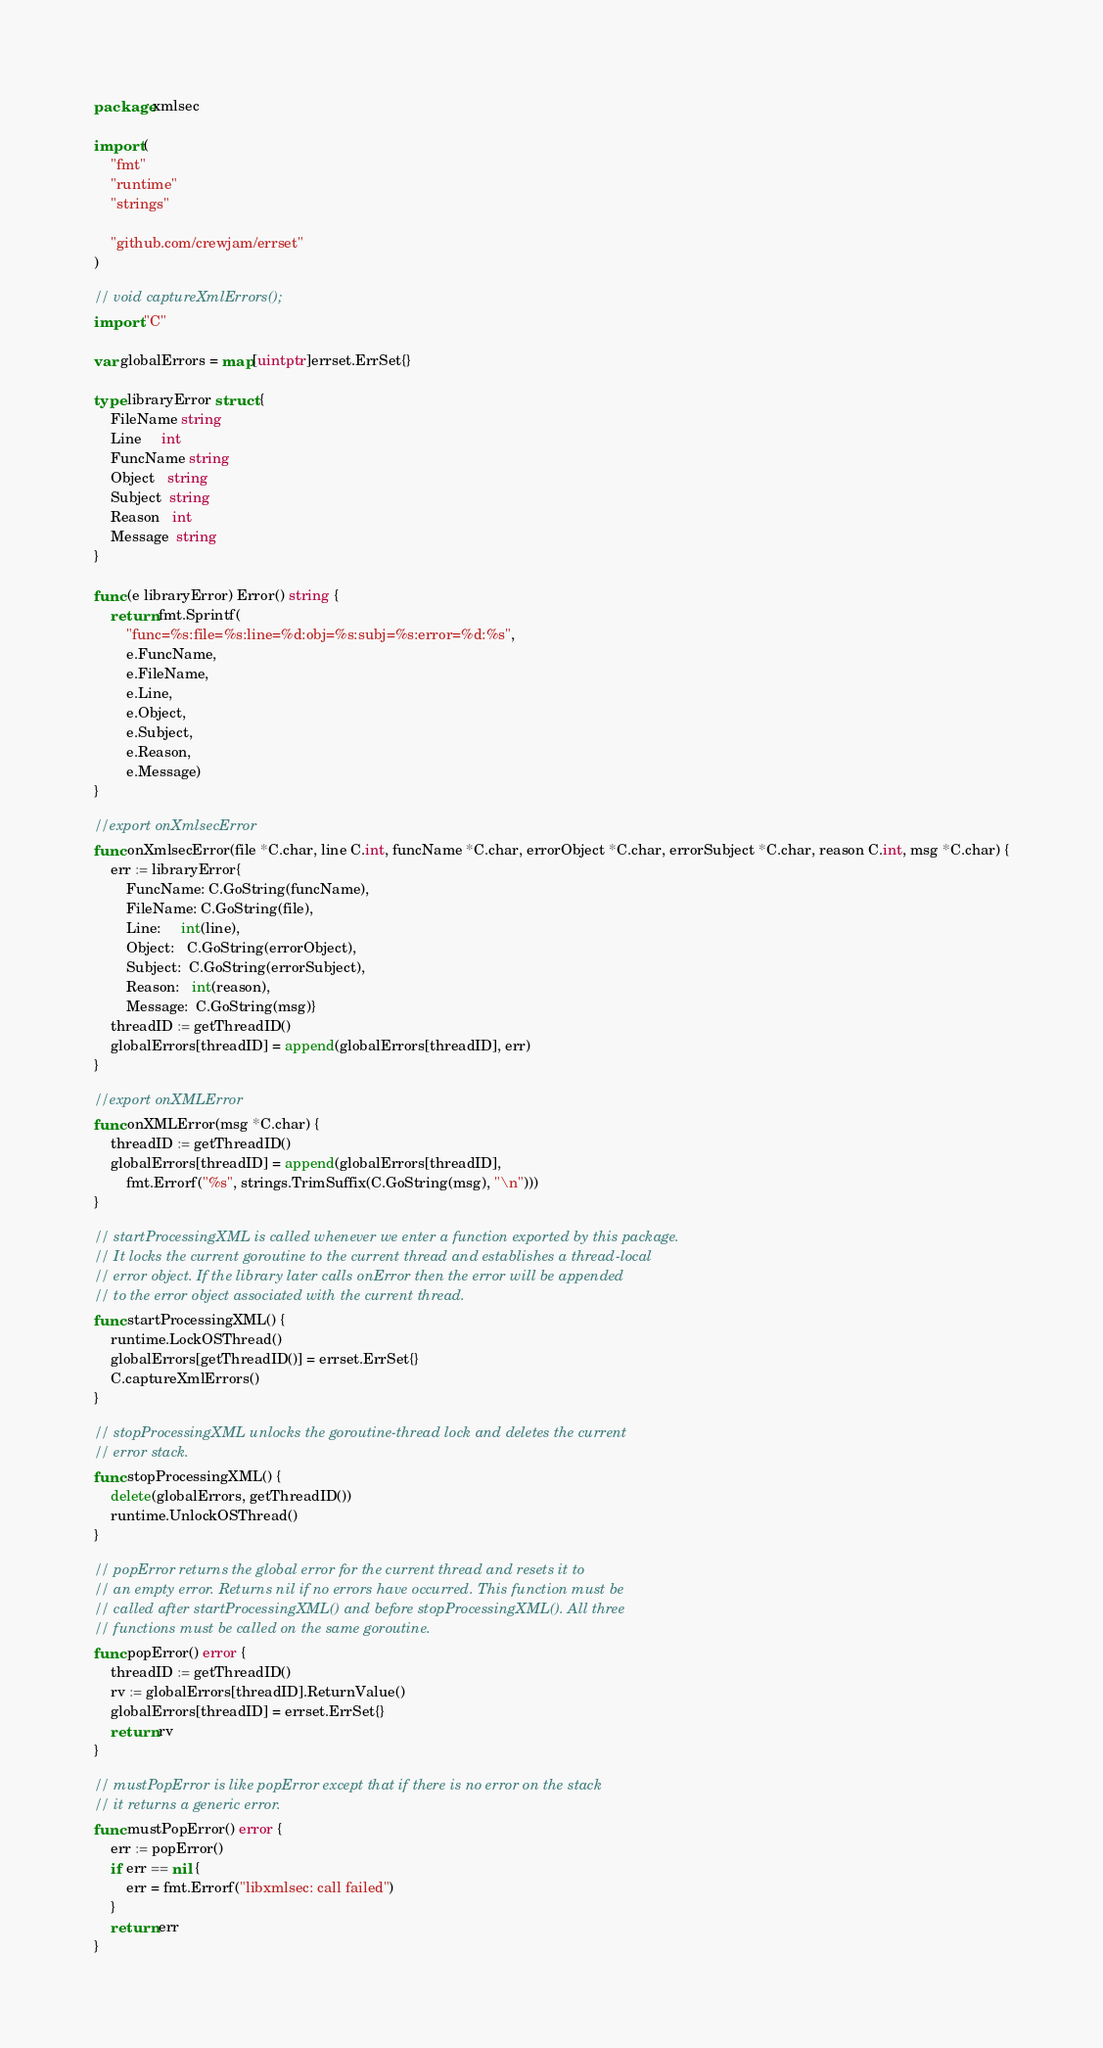<code> <loc_0><loc_0><loc_500><loc_500><_Go_>package xmlsec

import (
	"fmt"
	"runtime"
	"strings"

	"github.com/crewjam/errset"
)

// void captureXmlErrors();
import "C"

var globalErrors = map[uintptr]errset.ErrSet{}

type libraryError struct {
	FileName string
	Line     int
	FuncName string
	Object   string
	Subject  string
	Reason   int
	Message  string
}

func (e libraryError) Error() string {
	return fmt.Sprintf(
		"func=%s:file=%s:line=%d:obj=%s:subj=%s:error=%d:%s",
		e.FuncName,
		e.FileName,
		e.Line,
		e.Object,
		e.Subject,
		e.Reason,
		e.Message)
}

//export onXmlsecError
func onXmlsecError(file *C.char, line C.int, funcName *C.char, errorObject *C.char, errorSubject *C.char, reason C.int, msg *C.char) {
	err := libraryError{
		FuncName: C.GoString(funcName),
		FileName: C.GoString(file),
		Line:     int(line),
		Object:   C.GoString(errorObject),
		Subject:  C.GoString(errorSubject),
		Reason:   int(reason),
		Message:  C.GoString(msg)}
	threadID := getThreadID()
	globalErrors[threadID] = append(globalErrors[threadID], err)
}

//export onXMLError
func onXMLError(msg *C.char) {
	threadID := getThreadID()
	globalErrors[threadID] = append(globalErrors[threadID],
		fmt.Errorf("%s", strings.TrimSuffix(C.GoString(msg), "\n")))
}

// startProcessingXML is called whenever we enter a function exported by this package.
// It locks the current goroutine to the current thread and establishes a thread-local
// error object. If the library later calls onError then the error will be appended
// to the error object associated with the current thread.
func startProcessingXML() {
	runtime.LockOSThread()
	globalErrors[getThreadID()] = errset.ErrSet{}
	C.captureXmlErrors()
}

// stopProcessingXML unlocks the goroutine-thread lock and deletes the current
// error stack.
func stopProcessingXML() {
	delete(globalErrors, getThreadID())
	runtime.UnlockOSThread()
}

// popError returns the global error for the current thread and resets it to
// an empty error. Returns nil if no errors have occurred. This function must be
// called after startProcessingXML() and before stopProcessingXML(). All three
// functions must be called on the same goroutine.
func popError() error {
	threadID := getThreadID()
	rv := globalErrors[threadID].ReturnValue()
	globalErrors[threadID] = errset.ErrSet{}
	return rv
}

// mustPopError is like popError except that if there is no error on the stack
// it returns a generic error.
func mustPopError() error {
	err := popError()
	if err == nil {
		err = fmt.Errorf("libxmlsec: call failed")
	}
	return err
}
</code> 